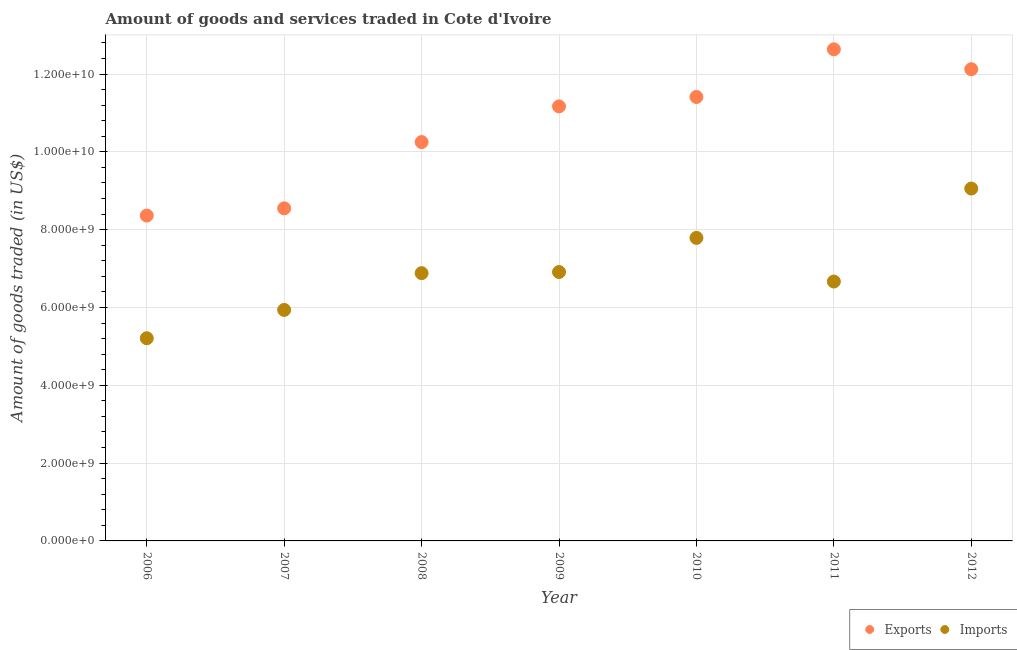Is the number of dotlines equal to the number of legend labels?
Your answer should be compact. Yes. What is the amount of goods imported in 2012?
Your answer should be very brief. 9.06e+09. Across all years, what is the maximum amount of goods exported?
Offer a very short reply. 1.26e+1. Across all years, what is the minimum amount of goods exported?
Provide a succinct answer. 8.36e+09. In which year was the amount of goods exported maximum?
Keep it short and to the point. 2011. In which year was the amount of goods imported minimum?
Provide a succinct answer. 2006. What is the total amount of goods imported in the graph?
Offer a very short reply. 4.85e+1. What is the difference between the amount of goods imported in 2006 and that in 2010?
Your answer should be compact. -2.58e+09. What is the difference between the amount of goods imported in 2006 and the amount of goods exported in 2008?
Your answer should be very brief. -5.04e+09. What is the average amount of goods imported per year?
Offer a terse response. 6.92e+09. In the year 2007, what is the difference between the amount of goods imported and amount of goods exported?
Keep it short and to the point. -2.61e+09. In how many years, is the amount of goods imported greater than 5600000000 US$?
Offer a terse response. 6. What is the ratio of the amount of goods exported in 2006 to that in 2011?
Provide a short and direct response. 0.66. Is the amount of goods imported in 2006 less than that in 2009?
Make the answer very short. Yes. Is the difference between the amount of goods exported in 2007 and 2012 greater than the difference between the amount of goods imported in 2007 and 2012?
Provide a succinct answer. No. What is the difference between the highest and the second highest amount of goods imported?
Offer a very short reply. 1.27e+09. What is the difference between the highest and the lowest amount of goods exported?
Ensure brevity in your answer.  4.27e+09. In how many years, is the amount of goods exported greater than the average amount of goods exported taken over all years?
Provide a short and direct response. 4. Is the sum of the amount of goods imported in 2009 and 2010 greater than the maximum amount of goods exported across all years?
Give a very brief answer. Yes. Is the amount of goods imported strictly greater than the amount of goods exported over the years?
Provide a succinct answer. No. Is the amount of goods imported strictly less than the amount of goods exported over the years?
Provide a short and direct response. Yes. How many dotlines are there?
Keep it short and to the point. 2. How many years are there in the graph?
Ensure brevity in your answer.  7. What is the difference between two consecutive major ticks on the Y-axis?
Make the answer very short. 2.00e+09. Does the graph contain any zero values?
Your answer should be compact. No. Does the graph contain grids?
Provide a succinct answer. Yes. Where does the legend appear in the graph?
Your answer should be very brief. Bottom right. How are the legend labels stacked?
Your response must be concise. Horizontal. What is the title of the graph?
Offer a terse response. Amount of goods and services traded in Cote d'Ivoire. Does "Birth rate" appear as one of the legend labels in the graph?
Offer a very short reply. No. What is the label or title of the X-axis?
Offer a terse response. Year. What is the label or title of the Y-axis?
Offer a terse response. Amount of goods traded (in US$). What is the Amount of goods traded (in US$) of Exports in 2006?
Offer a very short reply. 8.36e+09. What is the Amount of goods traded (in US$) of Imports in 2006?
Ensure brevity in your answer.  5.21e+09. What is the Amount of goods traded (in US$) in Exports in 2007?
Provide a succinct answer. 8.55e+09. What is the Amount of goods traded (in US$) in Imports in 2007?
Your response must be concise. 5.94e+09. What is the Amount of goods traded (in US$) in Exports in 2008?
Provide a succinct answer. 1.03e+1. What is the Amount of goods traded (in US$) in Imports in 2008?
Your answer should be very brief. 6.88e+09. What is the Amount of goods traded (in US$) of Exports in 2009?
Offer a very short reply. 1.12e+1. What is the Amount of goods traded (in US$) in Imports in 2009?
Your answer should be very brief. 6.91e+09. What is the Amount of goods traded (in US$) in Exports in 2010?
Make the answer very short. 1.14e+1. What is the Amount of goods traded (in US$) of Imports in 2010?
Offer a terse response. 7.79e+09. What is the Amount of goods traded (in US$) in Exports in 2011?
Ensure brevity in your answer.  1.26e+1. What is the Amount of goods traded (in US$) in Imports in 2011?
Offer a very short reply. 6.67e+09. What is the Amount of goods traded (in US$) of Exports in 2012?
Provide a short and direct response. 1.21e+1. What is the Amount of goods traded (in US$) in Imports in 2012?
Your answer should be very brief. 9.06e+09. Across all years, what is the maximum Amount of goods traded (in US$) of Exports?
Your response must be concise. 1.26e+1. Across all years, what is the maximum Amount of goods traded (in US$) of Imports?
Offer a terse response. 9.06e+09. Across all years, what is the minimum Amount of goods traded (in US$) in Exports?
Keep it short and to the point. 8.36e+09. Across all years, what is the minimum Amount of goods traded (in US$) of Imports?
Give a very brief answer. 5.21e+09. What is the total Amount of goods traded (in US$) of Exports in the graph?
Your answer should be compact. 7.45e+1. What is the total Amount of goods traded (in US$) of Imports in the graph?
Offer a very short reply. 4.85e+1. What is the difference between the Amount of goods traded (in US$) of Exports in 2006 and that in 2007?
Provide a short and direct response. -1.86e+08. What is the difference between the Amount of goods traded (in US$) of Imports in 2006 and that in 2007?
Offer a terse response. -7.28e+08. What is the difference between the Amount of goods traded (in US$) in Exports in 2006 and that in 2008?
Provide a short and direct response. -1.89e+09. What is the difference between the Amount of goods traded (in US$) of Imports in 2006 and that in 2008?
Give a very brief answer. -1.67e+09. What is the difference between the Amount of goods traded (in US$) of Exports in 2006 and that in 2009?
Make the answer very short. -2.81e+09. What is the difference between the Amount of goods traded (in US$) in Imports in 2006 and that in 2009?
Make the answer very short. -1.70e+09. What is the difference between the Amount of goods traded (in US$) in Exports in 2006 and that in 2010?
Provide a succinct answer. -3.05e+09. What is the difference between the Amount of goods traded (in US$) of Imports in 2006 and that in 2010?
Provide a succinct answer. -2.58e+09. What is the difference between the Amount of goods traded (in US$) of Exports in 2006 and that in 2011?
Offer a terse response. -4.27e+09. What is the difference between the Amount of goods traded (in US$) of Imports in 2006 and that in 2011?
Give a very brief answer. -1.46e+09. What is the difference between the Amount of goods traded (in US$) of Exports in 2006 and that in 2012?
Ensure brevity in your answer.  -3.76e+09. What is the difference between the Amount of goods traded (in US$) of Imports in 2006 and that in 2012?
Make the answer very short. -3.85e+09. What is the difference between the Amount of goods traded (in US$) of Exports in 2007 and that in 2008?
Provide a short and direct response. -1.70e+09. What is the difference between the Amount of goods traded (in US$) of Imports in 2007 and that in 2008?
Your response must be concise. -9.45e+08. What is the difference between the Amount of goods traded (in US$) in Exports in 2007 and that in 2009?
Provide a succinct answer. -2.62e+09. What is the difference between the Amount of goods traded (in US$) in Imports in 2007 and that in 2009?
Provide a succinct answer. -9.74e+08. What is the difference between the Amount of goods traded (in US$) in Exports in 2007 and that in 2010?
Your response must be concise. -2.86e+09. What is the difference between the Amount of goods traded (in US$) of Imports in 2007 and that in 2010?
Your answer should be very brief. -1.85e+09. What is the difference between the Amount of goods traded (in US$) in Exports in 2007 and that in 2011?
Give a very brief answer. -4.09e+09. What is the difference between the Amount of goods traded (in US$) of Imports in 2007 and that in 2011?
Keep it short and to the point. -7.30e+08. What is the difference between the Amount of goods traded (in US$) in Exports in 2007 and that in 2012?
Give a very brief answer. -3.58e+09. What is the difference between the Amount of goods traded (in US$) in Imports in 2007 and that in 2012?
Offer a terse response. -3.12e+09. What is the difference between the Amount of goods traded (in US$) of Exports in 2008 and that in 2009?
Give a very brief answer. -9.17e+08. What is the difference between the Amount of goods traded (in US$) of Imports in 2008 and that in 2009?
Give a very brief answer. -2.90e+07. What is the difference between the Amount of goods traded (in US$) of Exports in 2008 and that in 2010?
Offer a very short reply. -1.16e+09. What is the difference between the Amount of goods traded (in US$) in Imports in 2008 and that in 2010?
Provide a short and direct response. -9.06e+08. What is the difference between the Amount of goods traded (in US$) of Exports in 2008 and that in 2011?
Offer a terse response. -2.38e+09. What is the difference between the Amount of goods traded (in US$) of Imports in 2008 and that in 2011?
Your response must be concise. 2.16e+08. What is the difference between the Amount of goods traded (in US$) of Exports in 2008 and that in 2012?
Your answer should be very brief. -1.87e+09. What is the difference between the Amount of goods traded (in US$) of Imports in 2008 and that in 2012?
Provide a short and direct response. -2.17e+09. What is the difference between the Amount of goods traded (in US$) of Exports in 2009 and that in 2010?
Ensure brevity in your answer.  -2.42e+08. What is the difference between the Amount of goods traded (in US$) of Imports in 2009 and that in 2010?
Provide a short and direct response. -8.77e+08. What is the difference between the Amount of goods traded (in US$) of Exports in 2009 and that in 2011?
Provide a succinct answer. -1.47e+09. What is the difference between the Amount of goods traded (in US$) in Imports in 2009 and that in 2011?
Your response must be concise. 2.45e+08. What is the difference between the Amount of goods traded (in US$) in Exports in 2009 and that in 2012?
Give a very brief answer. -9.55e+08. What is the difference between the Amount of goods traded (in US$) in Imports in 2009 and that in 2012?
Give a very brief answer. -2.15e+09. What is the difference between the Amount of goods traded (in US$) of Exports in 2010 and that in 2011?
Make the answer very short. -1.22e+09. What is the difference between the Amount of goods traded (in US$) in Imports in 2010 and that in 2011?
Provide a short and direct response. 1.12e+09. What is the difference between the Amount of goods traded (in US$) in Exports in 2010 and that in 2012?
Give a very brief answer. -7.13e+08. What is the difference between the Amount of goods traded (in US$) of Imports in 2010 and that in 2012?
Your response must be concise. -1.27e+09. What is the difference between the Amount of goods traded (in US$) of Exports in 2011 and that in 2012?
Your answer should be very brief. 5.12e+08. What is the difference between the Amount of goods traded (in US$) in Imports in 2011 and that in 2012?
Make the answer very short. -2.39e+09. What is the difference between the Amount of goods traded (in US$) in Exports in 2006 and the Amount of goods traded (in US$) in Imports in 2007?
Your answer should be very brief. 2.43e+09. What is the difference between the Amount of goods traded (in US$) of Exports in 2006 and the Amount of goods traded (in US$) of Imports in 2008?
Offer a terse response. 1.48e+09. What is the difference between the Amount of goods traded (in US$) in Exports in 2006 and the Amount of goods traded (in US$) in Imports in 2009?
Your answer should be compact. 1.45e+09. What is the difference between the Amount of goods traded (in US$) of Exports in 2006 and the Amount of goods traded (in US$) of Imports in 2010?
Ensure brevity in your answer.  5.73e+08. What is the difference between the Amount of goods traded (in US$) of Exports in 2006 and the Amount of goods traded (in US$) of Imports in 2011?
Provide a short and direct response. 1.70e+09. What is the difference between the Amount of goods traded (in US$) of Exports in 2006 and the Amount of goods traded (in US$) of Imports in 2012?
Your answer should be very brief. -6.95e+08. What is the difference between the Amount of goods traded (in US$) in Exports in 2007 and the Amount of goods traded (in US$) in Imports in 2008?
Provide a succinct answer. 1.67e+09. What is the difference between the Amount of goods traded (in US$) of Exports in 2007 and the Amount of goods traded (in US$) of Imports in 2009?
Keep it short and to the point. 1.64e+09. What is the difference between the Amount of goods traded (in US$) of Exports in 2007 and the Amount of goods traded (in US$) of Imports in 2010?
Keep it short and to the point. 7.59e+08. What is the difference between the Amount of goods traded (in US$) in Exports in 2007 and the Amount of goods traded (in US$) in Imports in 2011?
Offer a terse response. 1.88e+09. What is the difference between the Amount of goods traded (in US$) of Exports in 2007 and the Amount of goods traded (in US$) of Imports in 2012?
Your response must be concise. -5.09e+08. What is the difference between the Amount of goods traded (in US$) in Exports in 2008 and the Amount of goods traded (in US$) in Imports in 2009?
Offer a very short reply. 3.34e+09. What is the difference between the Amount of goods traded (in US$) of Exports in 2008 and the Amount of goods traded (in US$) of Imports in 2010?
Give a very brief answer. 2.46e+09. What is the difference between the Amount of goods traded (in US$) of Exports in 2008 and the Amount of goods traded (in US$) of Imports in 2011?
Keep it short and to the point. 3.58e+09. What is the difference between the Amount of goods traded (in US$) of Exports in 2008 and the Amount of goods traded (in US$) of Imports in 2012?
Your answer should be very brief. 1.19e+09. What is the difference between the Amount of goods traded (in US$) of Exports in 2009 and the Amount of goods traded (in US$) of Imports in 2010?
Provide a succinct answer. 3.38e+09. What is the difference between the Amount of goods traded (in US$) of Exports in 2009 and the Amount of goods traded (in US$) of Imports in 2011?
Provide a short and direct response. 4.50e+09. What is the difference between the Amount of goods traded (in US$) of Exports in 2009 and the Amount of goods traded (in US$) of Imports in 2012?
Give a very brief answer. 2.11e+09. What is the difference between the Amount of goods traded (in US$) of Exports in 2010 and the Amount of goods traded (in US$) of Imports in 2011?
Your answer should be very brief. 4.74e+09. What is the difference between the Amount of goods traded (in US$) of Exports in 2010 and the Amount of goods traded (in US$) of Imports in 2012?
Offer a very short reply. 2.35e+09. What is the difference between the Amount of goods traded (in US$) in Exports in 2011 and the Amount of goods traded (in US$) in Imports in 2012?
Offer a very short reply. 3.58e+09. What is the average Amount of goods traded (in US$) in Exports per year?
Offer a very short reply. 1.06e+1. What is the average Amount of goods traded (in US$) in Imports per year?
Keep it short and to the point. 6.92e+09. In the year 2006, what is the difference between the Amount of goods traded (in US$) of Exports and Amount of goods traded (in US$) of Imports?
Your answer should be compact. 3.15e+09. In the year 2007, what is the difference between the Amount of goods traded (in US$) in Exports and Amount of goods traded (in US$) in Imports?
Make the answer very short. 2.61e+09. In the year 2008, what is the difference between the Amount of goods traded (in US$) in Exports and Amount of goods traded (in US$) in Imports?
Give a very brief answer. 3.37e+09. In the year 2009, what is the difference between the Amount of goods traded (in US$) in Exports and Amount of goods traded (in US$) in Imports?
Provide a succinct answer. 4.26e+09. In the year 2010, what is the difference between the Amount of goods traded (in US$) in Exports and Amount of goods traded (in US$) in Imports?
Make the answer very short. 3.62e+09. In the year 2011, what is the difference between the Amount of goods traded (in US$) of Exports and Amount of goods traded (in US$) of Imports?
Ensure brevity in your answer.  5.97e+09. In the year 2012, what is the difference between the Amount of goods traded (in US$) of Exports and Amount of goods traded (in US$) of Imports?
Your answer should be compact. 3.07e+09. What is the ratio of the Amount of goods traded (in US$) of Exports in 2006 to that in 2007?
Provide a short and direct response. 0.98. What is the ratio of the Amount of goods traded (in US$) in Imports in 2006 to that in 2007?
Ensure brevity in your answer.  0.88. What is the ratio of the Amount of goods traded (in US$) in Exports in 2006 to that in 2008?
Make the answer very short. 0.82. What is the ratio of the Amount of goods traded (in US$) of Imports in 2006 to that in 2008?
Offer a terse response. 0.76. What is the ratio of the Amount of goods traded (in US$) in Exports in 2006 to that in 2009?
Keep it short and to the point. 0.75. What is the ratio of the Amount of goods traded (in US$) in Imports in 2006 to that in 2009?
Your answer should be very brief. 0.75. What is the ratio of the Amount of goods traded (in US$) of Exports in 2006 to that in 2010?
Ensure brevity in your answer.  0.73. What is the ratio of the Amount of goods traded (in US$) of Imports in 2006 to that in 2010?
Your answer should be compact. 0.67. What is the ratio of the Amount of goods traded (in US$) in Exports in 2006 to that in 2011?
Your answer should be very brief. 0.66. What is the ratio of the Amount of goods traded (in US$) in Imports in 2006 to that in 2011?
Provide a short and direct response. 0.78. What is the ratio of the Amount of goods traded (in US$) of Exports in 2006 to that in 2012?
Your response must be concise. 0.69. What is the ratio of the Amount of goods traded (in US$) of Imports in 2006 to that in 2012?
Ensure brevity in your answer.  0.58. What is the ratio of the Amount of goods traded (in US$) of Exports in 2007 to that in 2008?
Give a very brief answer. 0.83. What is the ratio of the Amount of goods traded (in US$) of Imports in 2007 to that in 2008?
Give a very brief answer. 0.86. What is the ratio of the Amount of goods traded (in US$) in Exports in 2007 to that in 2009?
Give a very brief answer. 0.77. What is the ratio of the Amount of goods traded (in US$) of Imports in 2007 to that in 2009?
Offer a very short reply. 0.86. What is the ratio of the Amount of goods traded (in US$) in Exports in 2007 to that in 2010?
Your response must be concise. 0.75. What is the ratio of the Amount of goods traded (in US$) of Imports in 2007 to that in 2010?
Give a very brief answer. 0.76. What is the ratio of the Amount of goods traded (in US$) of Exports in 2007 to that in 2011?
Offer a very short reply. 0.68. What is the ratio of the Amount of goods traded (in US$) of Imports in 2007 to that in 2011?
Your response must be concise. 0.89. What is the ratio of the Amount of goods traded (in US$) of Exports in 2007 to that in 2012?
Your answer should be compact. 0.71. What is the ratio of the Amount of goods traded (in US$) of Imports in 2007 to that in 2012?
Offer a terse response. 0.66. What is the ratio of the Amount of goods traded (in US$) in Exports in 2008 to that in 2009?
Provide a short and direct response. 0.92. What is the ratio of the Amount of goods traded (in US$) of Imports in 2008 to that in 2009?
Give a very brief answer. 1. What is the ratio of the Amount of goods traded (in US$) in Exports in 2008 to that in 2010?
Your answer should be very brief. 0.9. What is the ratio of the Amount of goods traded (in US$) in Imports in 2008 to that in 2010?
Give a very brief answer. 0.88. What is the ratio of the Amount of goods traded (in US$) of Exports in 2008 to that in 2011?
Your answer should be very brief. 0.81. What is the ratio of the Amount of goods traded (in US$) in Imports in 2008 to that in 2011?
Your answer should be compact. 1.03. What is the ratio of the Amount of goods traded (in US$) in Exports in 2008 to that in 2012?
Your answer should be compact. 0.85. What is the ratio of the Amount of goods traded (in US$) in Imports in 2008 to that in 2012?
Your answer should be compact. 0.76. What is the ratio of the Amount of goods traded (in US$) of Exports in 2009 to that in 2010?
Give a very brief answer. 0.98. What is the ratio of the Amount of goods traded (in US$) in Imports in 2009 to that in 2010?
Ensure brevity in your answer.  0.89. What is the ratio of the Amount of goods traded (in US$) in Exports in 2009 to that in 2011?
Your response must be concise. 0.88. What is the ratio of the Amount of goods traded (in US$) of Imports in 2009 to that in 2011?
Make the answer very short. 1.04. What is the ratio of the Amount of goods traded (in US$) of Exports in 2009 to that in 2012?
Ensure brevity in your answer.  0.92. What is the ratio of the Amount of goods traded (in US$) in Imports in 2009 to that in 2012?
Make the answer very short. 0.76. What is the ratio of the Amount of goods traded (in US$) of Exports in 2010 to that in 2011?
Ensure brevity in your answer.  0.9. What is the ratio of the Amount of goods traded (in US$) of Imports in 2010 to that in 2011?
Give a very brief answer. 1.17. What is the ratio of the Amount of goods traded (in US$) in Exports in 2010 to that in 2012?
Ensure brevity in your answer.  0.94. What is the ratio of the Amount of goods traded (in US$) of Imports in 2010 to that in 2012?
Make the answer very short. 0.86. What is the ratio of the Amount of goods traded (in US$) of Exports in 2011 to that in 2012?
Give a very brief answer. 1.04. What is the ratio of the Amount of goods traded (in US$) in Imports in 2011 to that in 2012?
Offer a terse response. 0.74. What is the difference between the highest and the second highest Amount of goods traded (in US$) in Exports?
Your answer should be very brief. 5.12e+08. What is the difference between the highest and the second highest Amount of goods traded (in US$) of Imports?
Give a very brief answer. 1.27e+09. What is the difference between the highest and the lowest Amount of goods traded (in US$) in Exports?
Give a very brief answer. 4.27e+09. What is the difference between the highest and the lowest Amount of goods traded (in US$) in Imports?
Your answer should be very brief. 3.85e+09. 